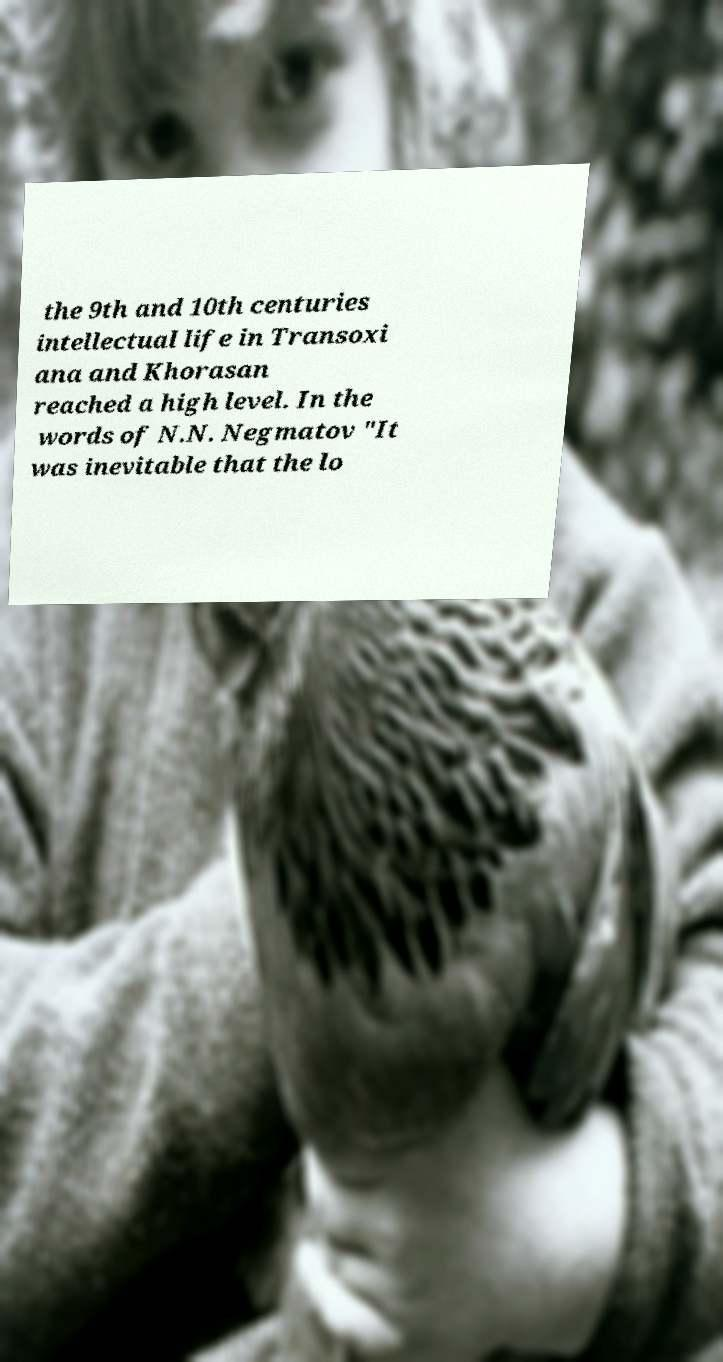For documentation purposes, I need the text within this image transcribed. Could you provide that? the 9th and 10th centuries intellectual life in Transoxi ana and Khorasan reached a high level. In the words of N.N. Negmatov "It was inevitable that the lo 